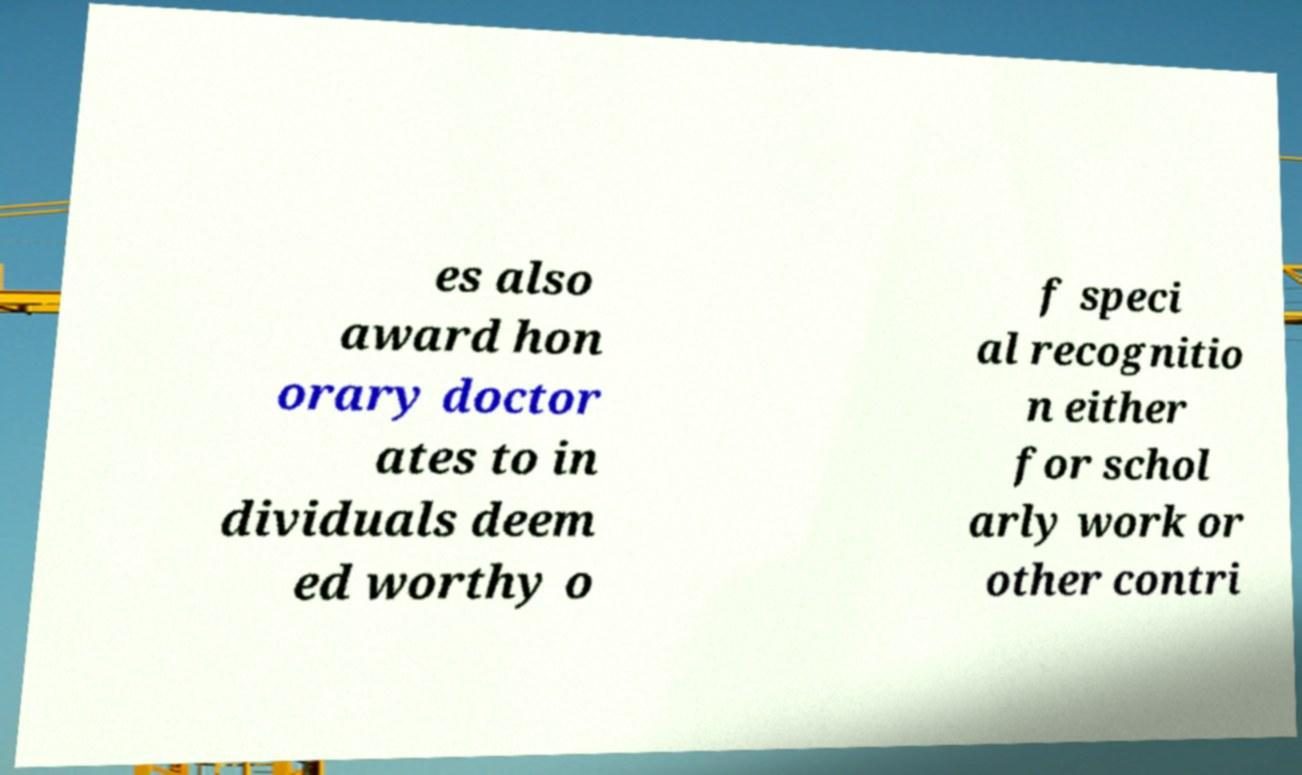Could you assist in decoding the text presented in this image and type it out clearly? es also award hon orary doctor ates to in dividuals deem ed worthy o f speci al recognitio n either for schol arly work or other contri 